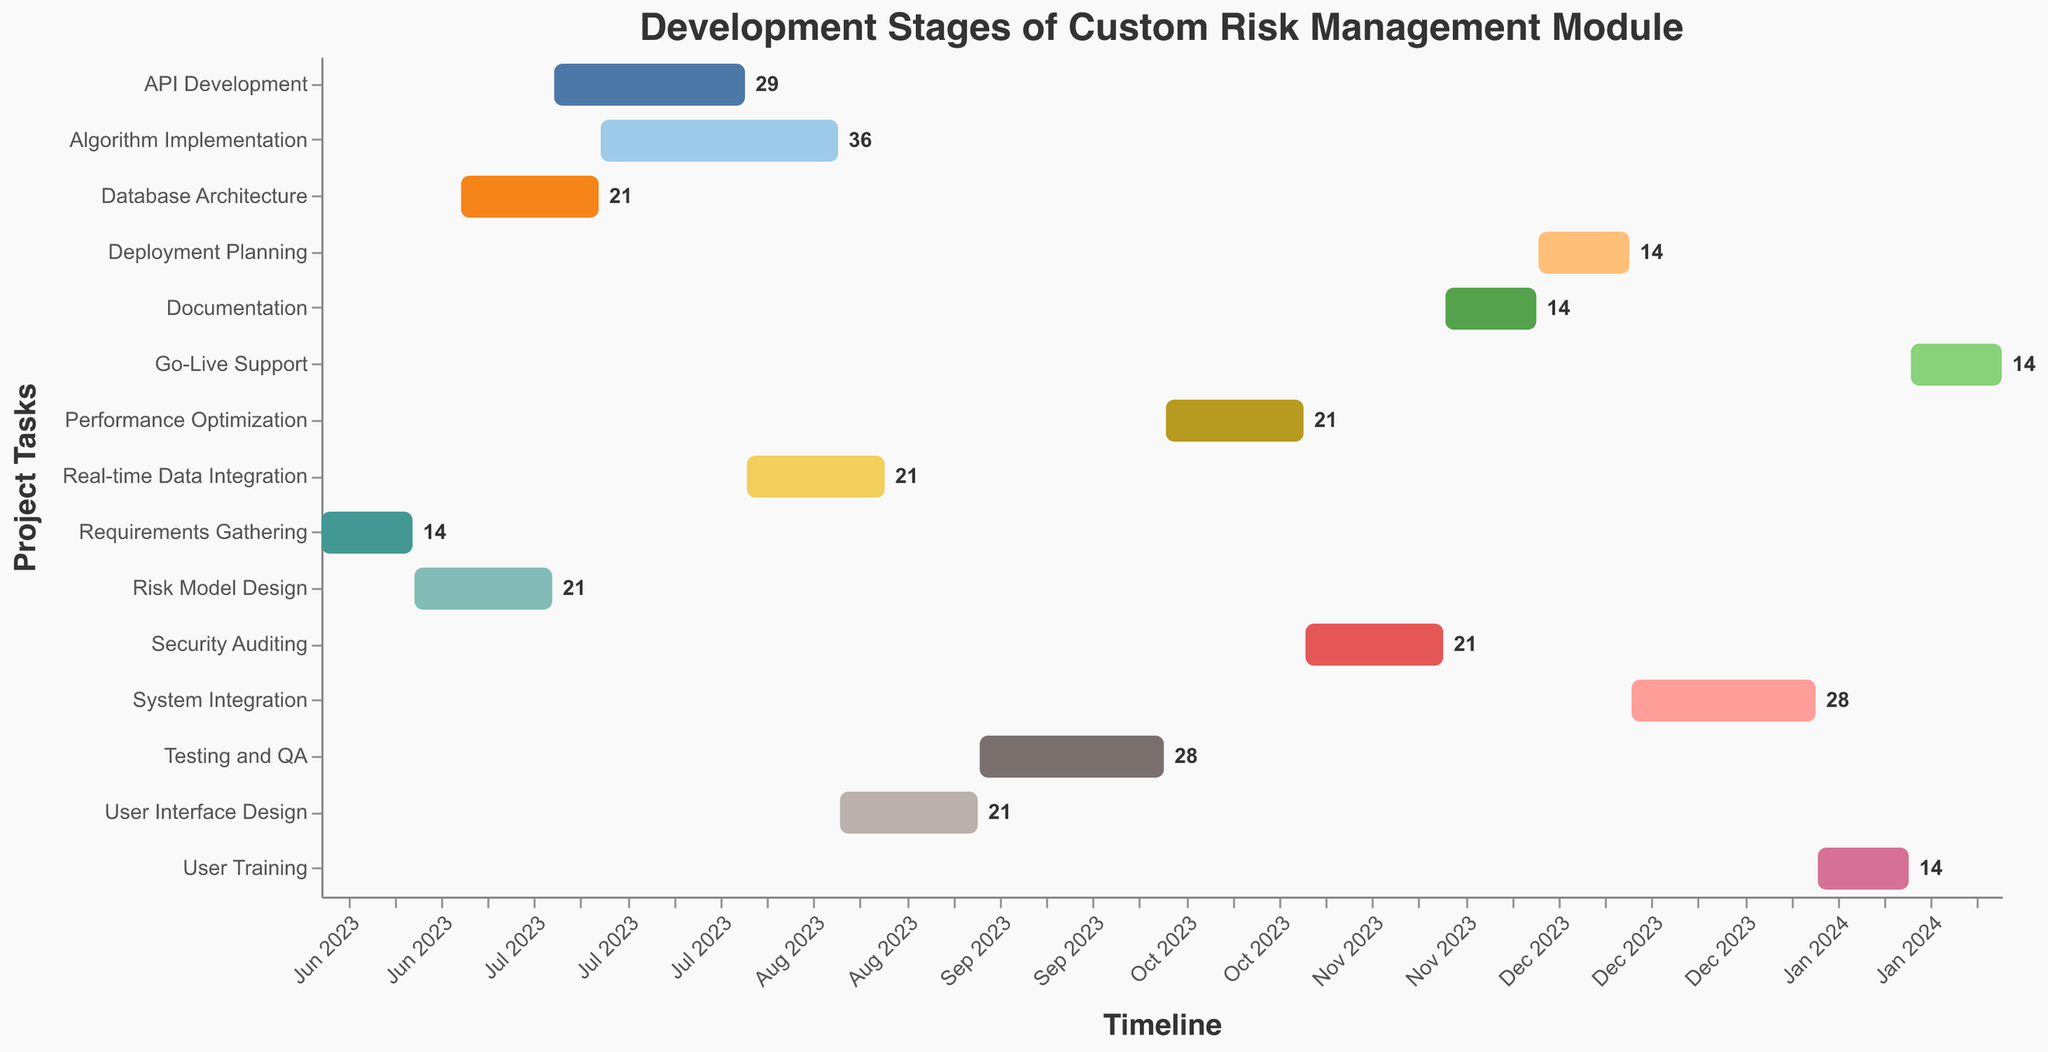What's the total duration of the entire project? To find the total duration, identify the start date of the first task and the end date of the last task. The project starts on June 1, 2023, and ends on February 8, 2024. Calculate the number of days between these dates.
Answer: 253 days Which task has the longest duration, and what's its duration? Examine the duration values for each task. Identify the task with the highest duration value, which is "Algorithm Implementation" with a duration of 36 days.
Answer: Algorithm Implementation, 36 days When does the "Testing and QA" phase start and end? Locate the "Testing and QA" task on the Y-axis. Check its start date and end date from the chart's tooltip. The start date is September 8, 2023, and the end date is October 5, 2023.
Answer: September 8, 2023 - October 5, 2023 Which phase overlaps with "Database Architecture" and by how many days? Find the "Database Architecture" task and its start and end dates (June 22, 2023 - July 12, 2023). Identify tasks that overlap with this period. "Risk Model Design" (June 15, 2023 - July 5, 2023) overlaps by 14 days.
Answer: Risk Model Design, 14 days How many tasks have a duration of exactly 21 days? Look at the duration values for each task. Count the tasks with a duration of 21 days. They are "Risk Model Design," "Database Architecture," "Real-time Data Integration," "User Interface Design," "Performance Optimization," and "Security Auditing," totaling six tasks.
Answer: 6 tasks Which task starts immediately after "Documentation"? Locate the "Documentation" task and check its end date (November 30, 2023). The task starting right after that date is "Deployment Planning," which starts on December 1, 2023.
Answer: Deployment Planning When is the project expected to reach the "Go-Live Support" stage and how long does it last? Identify the start and end dates for "Go-Live Support." It starts on January 26, 2024, and ends on February 8, 2024, lasting 14 days.
Answer: January 26, 2024 - February 8, 2024, 14 days How many tasks are planned to be concurrently active in August 2023? Identify tasks active in August by noting their start and end dates. "API Development," "Algorithm Implementation," "Real-time Data Integration," and "User Interface Design" are active during August.
Answer: 4 tasks Which task is planned to be the last in the project timeline? Check the end dates of all tasks. The last task to end is "Go-Live Support," which concludes on February 8, 2024.
Answer: Go-Live Support How much time will elapse from the end of "System Integration" to the start of "Go-Live Support"? Determine the end date of "System Integration" (January 11, 2024) and the start date of "Go-Live Support" (January 26, 2024). Calculate the difference between these dates.
Answer: 15 days 